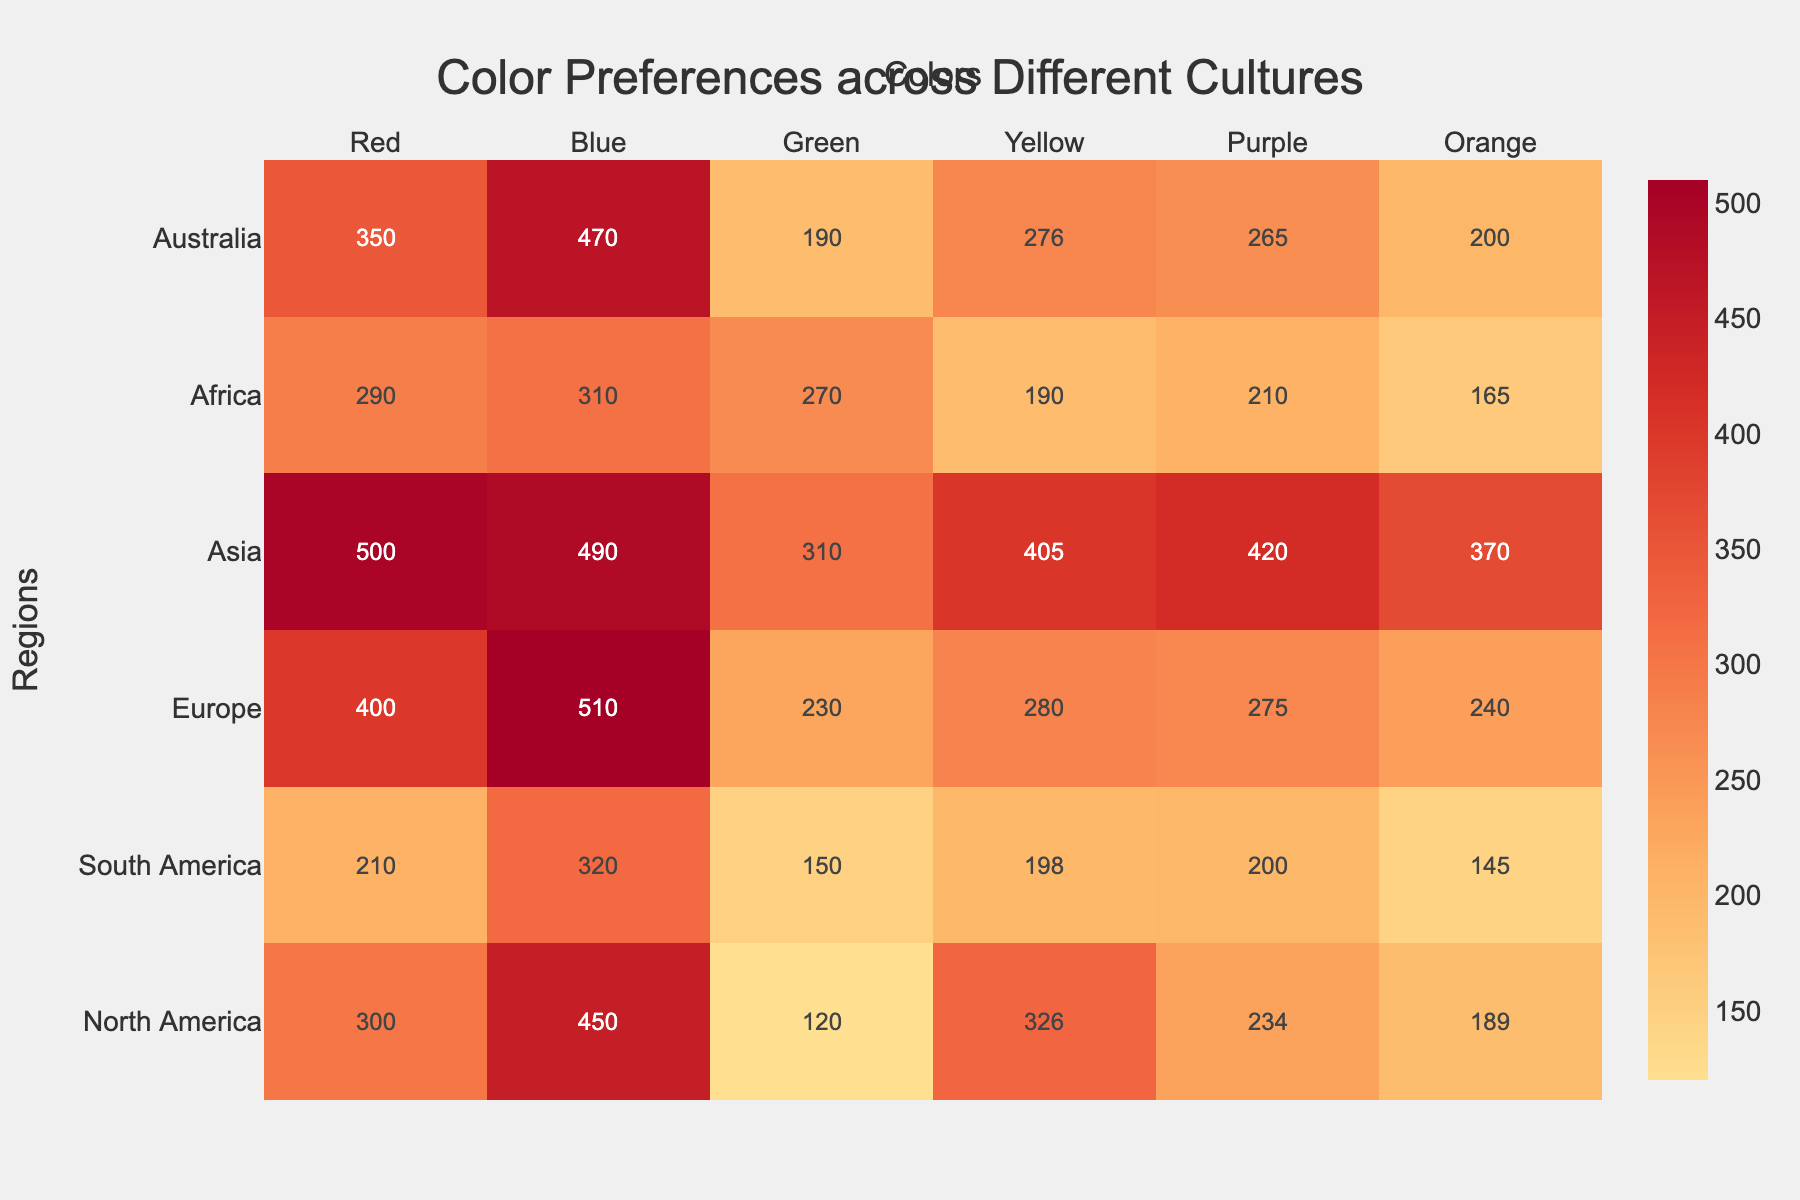What's the title of the heatmap? The title of the heatmap is usually found at the top of the figure, typically displayed in a larger and more prominent font. In this case, the title "Color Preferences across Different Cultures" is centrally located at the top.
Answer: Color Preferences across Different Cultures Which region has the highest preference for the color Red? To determine this, look at the color intensity in the heatmap's row for "Red" and compare the values. The region with the highest value here is Asia, as indicated by the darker shade corresponding to the value 500.
Answer: Asia Which color has the highest overall preference in Europe? Examine the row corresponding to Europe and identify the highest value among all colors. In this row, Blue has the highest value, which is 510.
Answer: Blue Compare the preference for Yellow between North America and Africa. Which one is higher and by how much? Check the values for Yellow in both North America and Africa rows. North America has 326 while Africa has 190. The difference is calculated as 326 - 190.
Answer: North America by 136 What's the sum of preferences for Orange in all regions? To find the sum, add the Orange values from all regions: 189 (North America) + 145 (South America) + 240 (Europe) + 370 (Asia) + 165 (Africa) + 200 (Australia). The sum is: 1309.
Answer: 1309 Which region shows the largest preference for the color Green, and what is the value? Identify the highest value in the Green column across all regions. Asia has the highest value, which is 310.
Answer: Asia, 310 What is the average preference value for Red across all regions? To calculate the average, sum the values for Red in all regions and divide by the number of regions. (300 + 210 + 400 + 500 + 290 + 350) / 6 = 2050 / 6. The average is approximately 341.67.
Answer: 341.67 Which region has the lowest preference for colors overall? Calculate the sum of preferences for all colors in each region, and identify the lowest sum. North America: 300+450+120+326+234+189=1619, South America: 210+320+150+198+200+145=1223, Europe: 400+510+230+280+275+240=1935, Asia: 500+490+310+405+420+370=2495, Africa: 290+310+270+190+210+165=1435, Australia: 350+470+190+276+265+200=1751. South America has the lowest sum, 1223.
Answer: South America Is the preference for Green in Africa higher than in South America? Compare the values for Green between Africa and South America. Africa has 270, while South America has 150. Since 270 > 150, the preference is higher in Africa.
Answer: Yes 